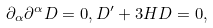<formula> <loc_0><loc_0><loc_500><loc_500>\partial _ { \alpha } \partial ^ { \alpha } D = 0 , D ^ { \prime } + 3 H D = 0 ,</formula> 